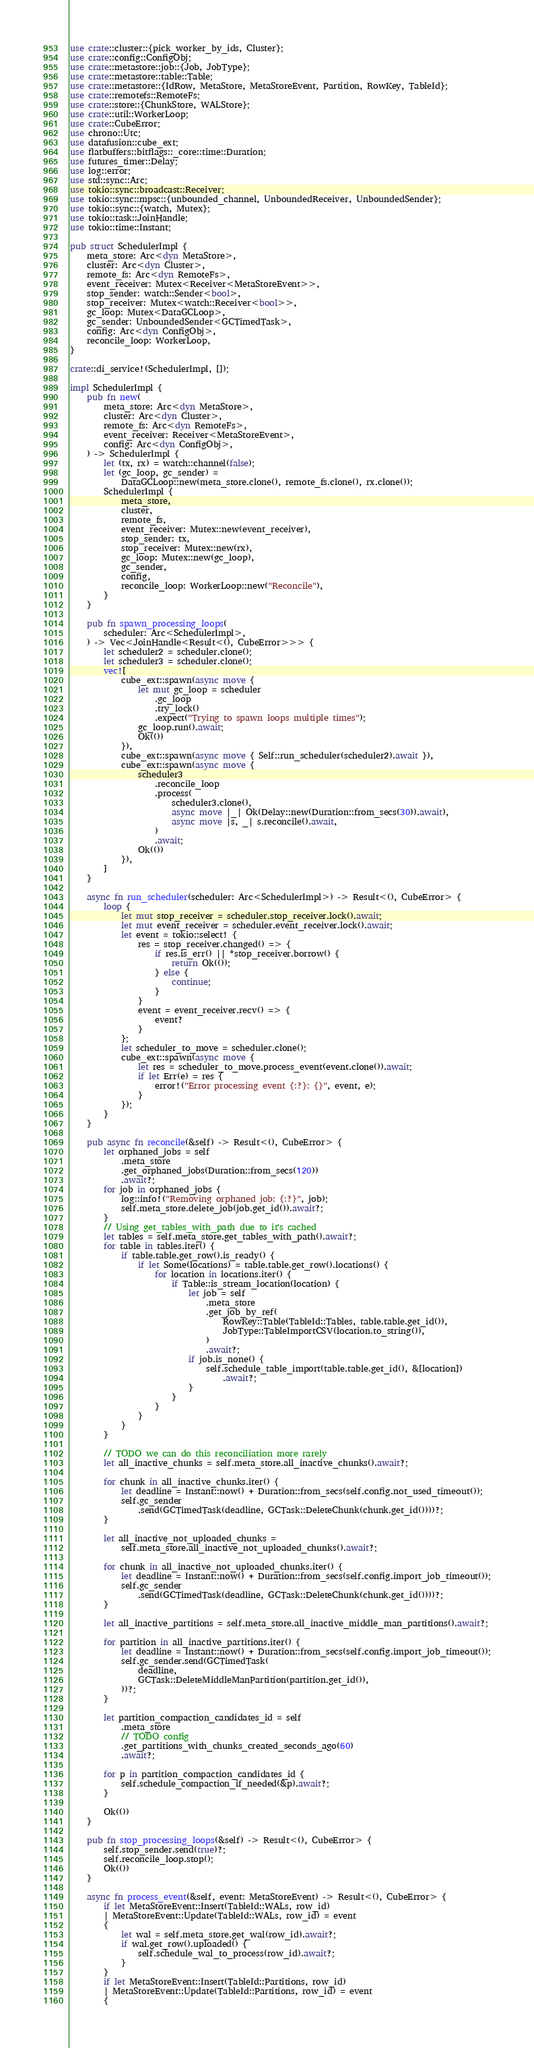<code> <loc_0><loc_0><loc_500><loc_500><_Rust_>use crate::cluster::{pick_worker_by_ids, Cluster};
use crate::config::ConfigObj;
use crate::metastore::job::{Job, JobType};
use crate::metastore::table::Table;
use crate::metastore::{IdRow, MetaStore, MetaStoreEvent, Partition, RowKey, TableId};
use crate::remotefs::RemoteFs;
use crate::store::{ChunkStore, WALStore};
use crate::util::WorkerLoop;
use crate::CubeError;
use chrono::Utc;
use datafusion::cube_ext;
use flatbuffers::bitflags::_core::time::Duration;
use futures_timer::Delay;
use log::error;
use std::sync::Arc;
use tokio::sync::broadcast::Receiver;
use tokio::sync::mpsc::{unbounded_channel, UnboundedReceiver, UnboundedSender};
use tokio::sync::{watch, Mutex};
use tokio::task::JoinHandle;
use tokio::time::Instant;

pub struct SchedulerImpl {
    meta_store: Arc<dyn MetaStore>,
    cluster: Arc<dyn Cluster>,
    remote_fs: Arc<dyn RemoteFs>,
    event_receiver: Mutex<Receiver<MetaStoreEvent>>,
    stop_sender: watch::Sender<bool>,
    stop_receiver: Mutex<watch::Receiver<bool>>,
    gc_loop: Mutex<DataGCLoop>,
    gc_sender: UnboundedSender<GCTimedTask>,
    config: Arc<dyn ConfigObj>,
    reconcile_loop: WorkerLoop,
}

crate::di_service!(SchedulerImpl, []);

impl SchedulerImpl {
    pub fn new(
        meta_store: Arc<dyn MetaStore>,
        cluster: Arc<dyn Cluster>,
        remote_fs: Arc<dyn RemoteFs>,
        event_receiver: Receiver<MetaStoreEvent>,
        config: Arc<dyn ConfigObj>,
    ) -> SchedulerImpl {
        let (tx, rx) = watch::channel(false);
        let (gc_loop, gc_sender) =
            DataGCLoop::new(meta_store.clone(), remote_fs.clone(), rx.clone());
        SchedulerImpl {
            meta_store,
            cluster,
            remote_fs,
            event_receiver: Mutex::new(event_receiver),
            stop_sender: tx,
            stop_receiver: Mutex::new(rx),
            gc_loop: Mutex::new(gc_loop),
            gc_sender,
            config,
            reconcile_loop: WorkerLoop::new("Reconcile"),
        }
    }

    pub fn spawn_processing_loops(
        scheduler: Arc<SchedulerImpl>,
    ) -> Vec<JoinHandle<Result<(), CubeError>>> {
        let scheduler2 = scheduler.clone();
        let scheduler3 = scheduler.clone();
        vec![
            cube_ext::spawn(async move {
                let mut gc_loop = scheduler
                    .gc_loop
                    .try_lock()
                    .expect("Trying to spawn loops multiple times");
                gc_loop.run().await;
                Ok(())
            }),
            cube_ext::spawn(async move { Self::run_scheduler(scheduler2).await }),
            cube_ext::spawn(async move {
                scheduler3
                    .reconcile_loop
                    .process(
                        scheduler3.clone(),
                        async move |_| Ok(Delay::new(Duration::from_secs(30)).await),
                        async move |s, _| s.reconcile().await,
                    )
                    .await;
                Ok(())
            }),
        ]
    }

    async fn run_scheduler(scheduler: Arc<SchedulerImpl>) -> Result<(), CubeError> {
        loop {
            let mut stop_receiver = scheduler.stop_receiver.lock().await;
            let mut event_receiver = scheduler.event_receiver.lock().await;
            let event = tokio::select! {
                res = stop_receiver.changed() => {
                    if res.is_err() || *stop_receiver.borrow() {
                        return Ok(());
                    } else {
                        continue;
                    }
                }
                event = event_receiver.recv() => {
                    event?
                }
            };
            let scheduler_to_move = scheduler.clone();
            cube_ext::spawn(async move {
                let res = scheduler_to_move.process_event(event.clone()).await;
                if let Err(e) = res {
                    error!("Error processing event {:?}: {}", event, e);
                }
            });
        }
    }

    pub async fn reconcile(&self) -> Result<(), CubeError> {
        let orphaned_jobs = self
            .meta_store
            .get_orphaned_jobs(Duration::from_secs(120))
            .await?;
        for job in orphaned_jobs {
            log::info!("Removing orphaned job: {:?}", job);
            self.meta_store.delete_job(job.get_id()).await?;
        }
        // Using get_tables_with_path due to it's cached
        let tables = self.meta_store.get_tables_with_path().await?;
        for table in tables.iter() {
            if table.table.get_row().is_ready() {
                if let Some(locations) = table.table.get_row().locations() {
                    for location in locations.iter() {
                        if Table::is_stream_location(location) {
                            let job = self
                                .meta_store
                                .get_job_by_ref(
                                    RowKey::Table(TableId::Tables, table.table.get_id()),
                                    JobType::TableImportCSV(location.to_string()),
                                )
                                .await?;
                            if job.is_none() {
                                self.schedule_table_import(table.table.get_id(), &[location])
                                    .await?;
                            }
                        }
                    }
                }
            }
        }

        // TODO we can do this reconciliation more rarely
        let all_inactive_chunks = self.meta_store.all_inactive_chunks().await?;

        for chunk in all_inactive_chunks.iter() {
            let deadline = Instant::now() + Duration::from_secs(self.config.not_used_timeout());
            self.gc_sender
                .send(GCTimedTask(deadline, GCTask::DeleteChunk(chunk.get_id())))?;
        }

        let all_inactive_not_uploaded_chunks =
            self.meta_store.all_inactive_not_uploaded_chunks().await?;

        for chunk in all_inactive_not_uploaded_chunks.iter() {
            let deadline = Instant::now() + Duration::from_secs(self.config.import_job_timeout());
            self.gc_sender
                .send(GCTimedTask(deadline, GCTask::DeleteChunk(chunk.get_id())))?;
        }

        let all_inactive_partitions = self.meta_store.all_inactive_middle_man_partitions().await?;

        for partition in all_inactive_partitions.iter() {
            let deadline = Instant::now() + Duration::from_secs(self.config.import_job_timeout());
            self.gc_sender.send(GCTimedTask(
                deadline,
                GCTask::DeleteMiddleManPartition(partition.get_id()),
            ))?;
        }

        let partition_compaction_candidates_id = self
            .meta_store
            // TODO config
            .get_partitions_with_chunks_created_seconds_ago(60)
            .await?;

        for p in partition_compaction_candidates_id {
            self.schedule_compaction_if_needed(&p).await?;
        }

        Ok(())
    }

    pub fn stop_processing_loops(&self) -> Result<(), CubeError> {
        self.stop_sender.send(true)?;
        self.reconcile_loop.stop();
        Ok(())
    }

    async fn process_event(&self, event: MetaStoreEvent) -> Result<(), CubeError> {
        if let MetaStoreEvent::Insert(TableId::WALs, row_id)
        | MetaStoreEvent::Update(TableId::WALs, row_id) = event
        {
            let wal = self.meta_store.get_wal(row_id).await?;
            if wal.get_row().uploaded() {
                self.schedule_wal_to_process(row_id).await?;
            }
        }
        if let MetaStoreEvent::Insert(TableId::Partitions, row_id)
        | MetaStoreEvent::Update(TableId::Partitions, row_id) = event
        {</code> 